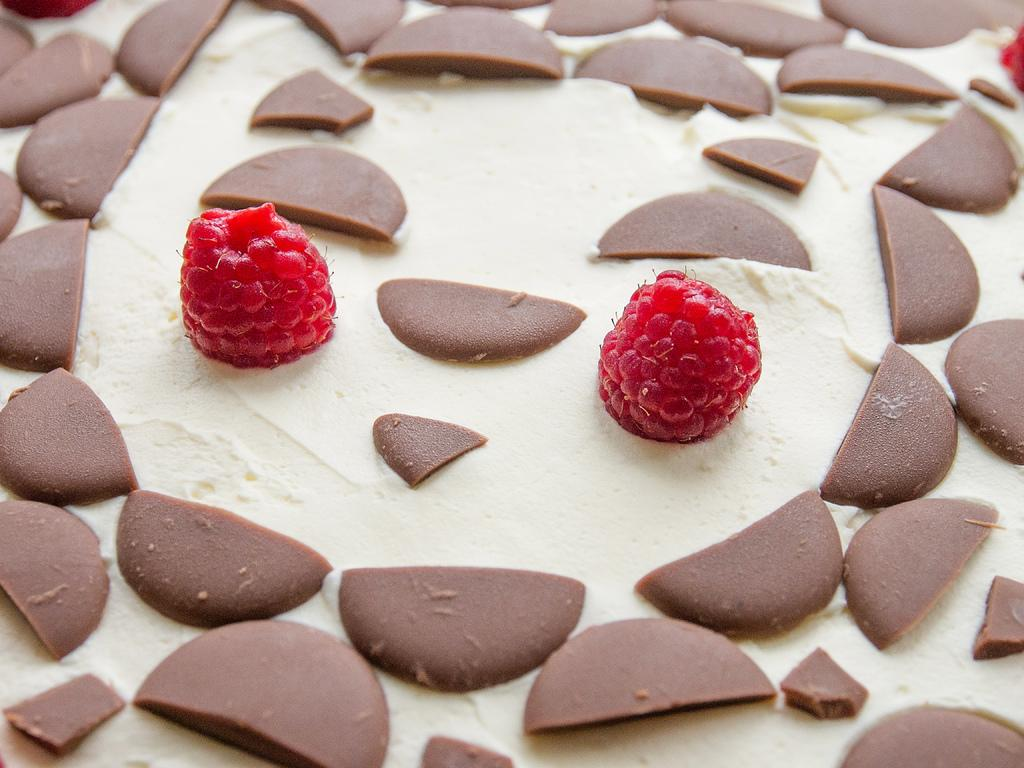What is the main subject of the image? The image is of a food item. Can you describe the food item in more detail? There are two berries in the center of the image. How many forks are visible in the image? There are no forks present in the image. Can you provide an example of a line in the image? There are no lines present in the image; it is a close-up of two berries. 